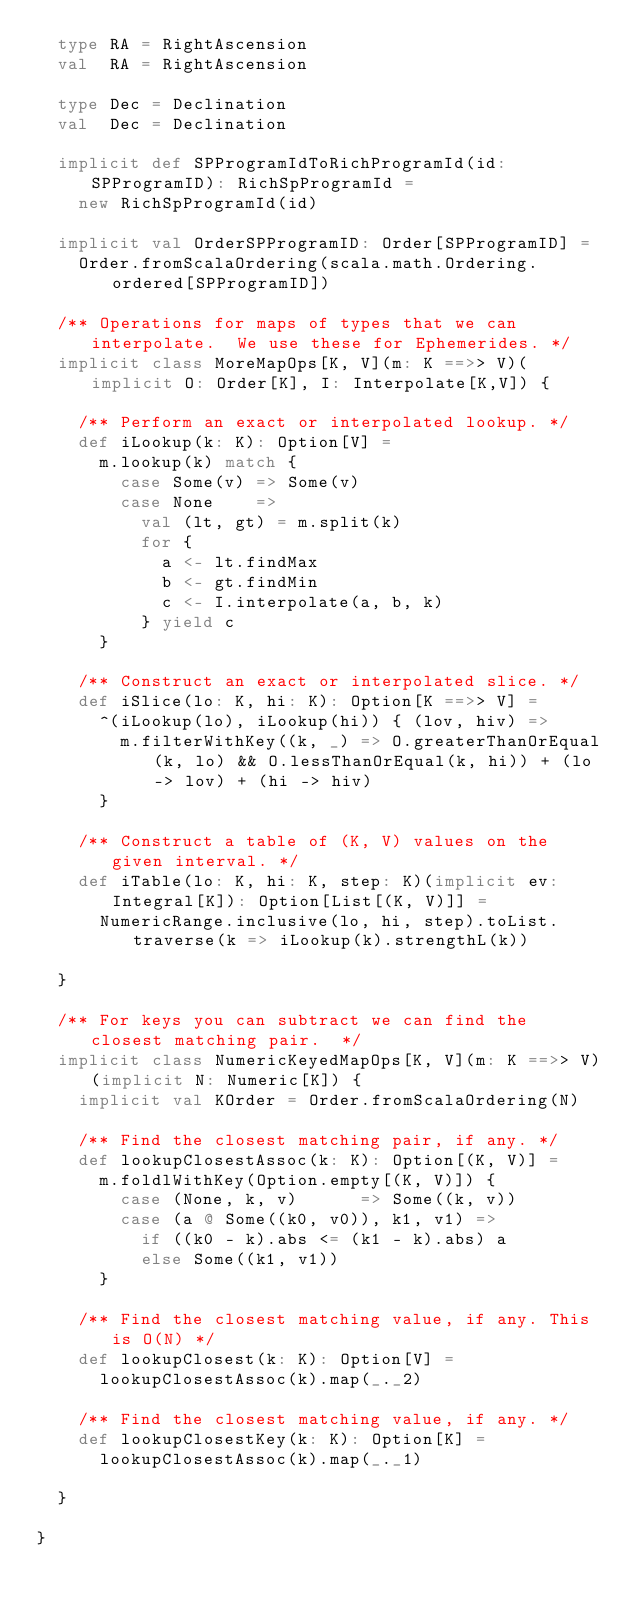<code> <loc_0><loc_0><loc_500><loc_500><_Scala_>  type RA = RightAscension
  val  RA = RightAscension

  type Dec = Declination
  val  Dec = Declination

  implicit def SPProgramIdToRichProgramId(id: SPProgramID): RichSpProgramId =
    new RichSpProgramId(id)

  implicit val OrderSPProgramID: Order[SPProgramID] =
    Order.fromScalaOrdering(scala.math.Ordering.ordered[SPProgramID])

  /** Operations for maps of types that we can interpolate.  We use these for Ephemerides. */
  implicit class MoreMapOps[K, V](m: K ==>> V)(implicit O: Order[K], I: Interpolate[K,V]) {

    /** Perform an exact or interpolated lookup. */
    def iLookup(k: K): Option[V] =
      m.lookup(k) match {
        case Some(v) => Some(v)
        case None    =>
          val (lt, gt) = m.split(k)
          for {
            a <- lt.findMax
            b <- gt.findMin
            c <- I.interpolate(a, b, k)
          } yield c
      }

    /** Construct an exact or interpolated slice. */
    def iSlice(lo: K, hi: K): Option[K ==>> V] =
      ^(iLookup(lo), iLookup(hi)) { (lov, hiv) =>
        m.filterWithKey((k, _) => O.greaterThanOrEqual(k, lo) && O.lessThanOrEqual(k, hi)) + (lo -> lov) + (hi -> hiv)
      }

    /** Construct a table of (K, V) values on the given interval. */
    def iTable(lo: K, hi: K, step: K)(implicit ev: Integral[K]): Option[List[(K, V)]] =
      NumericRange.inclusive(lo, hi, step).toList.traverse(k => iLookup(k).strengthL(k))

  }

  /** For keys you can subtract we can find the closest matching pair.  */
  implicit class NumericKeyedMapOps[K, V](m: K ==>> V)(implicit N: Numeric[K]) {
    implicit val KOrder = Order.fromScalaOrdering(N)

    /** Find the closest matching pair, if any. */
    def lookupClosestAssoc(k: K): Option[(K, V)] =
      m.foldlWithKey(Option.empty[(K, V)]) {
        case (None, k, v)      => Some((k, v))
        case (a @ Some((k0, v0)), k1, v1) =>
          if ((k0 - k).abs <= (k1 - k).abs) a
          else Some((k1, v1))
      }

    /** Find the closest matching value, if any. This is O(N) */
    def lookupClosest(k: K): Option[V] =
      lookupClosestAssoc(k).map(_._2)

    /** Find the closest matching value, if any. */
    def lookupClosestKey(k: K): Option[K] =
      lookupClosestAssoc(k).map(_._1)

  }

}

</code> 